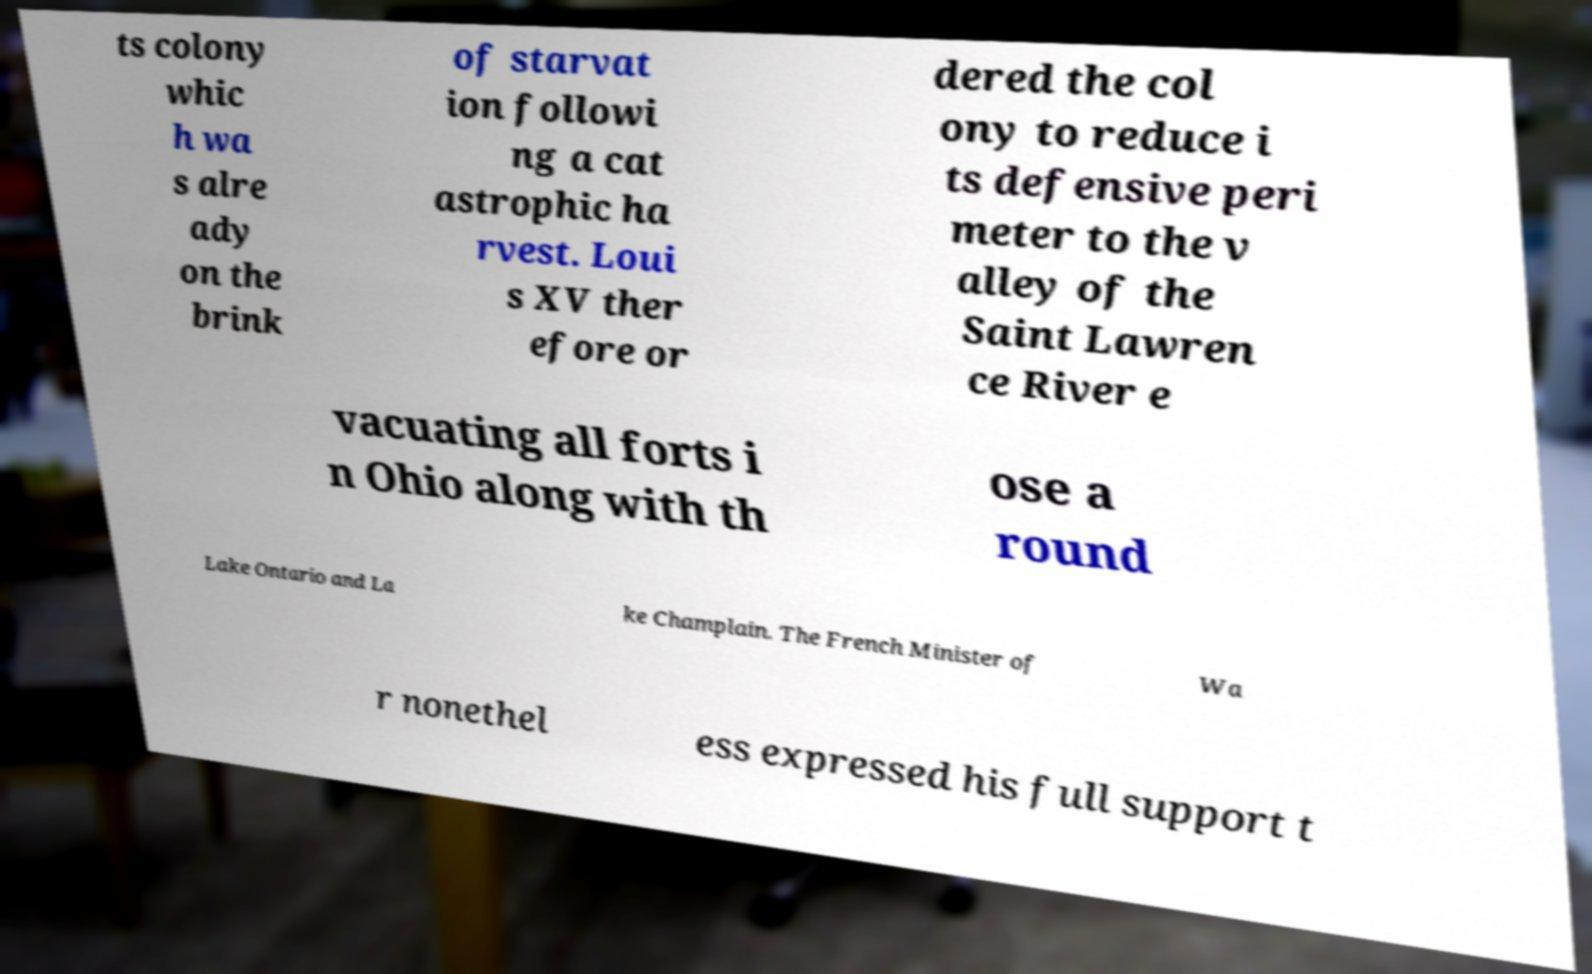Can you read and provide the text displayed in the image?This photo seems to have some interesting text. Can you extract and type it out for me? ts colony whic h wa s alre ady on the brink of starvat ion followi ng a cat astrophic ha rvest. Loui s XV ther efore or dered the col ony to reduce i ts defensive peri meter to the v alley of the Saint Lawren ce River e vacuating all forts i n Ohio along with th ose a round Lake Ontario and La ke Champlain. The French Minister of Wa r nonethel ess expressed his full support t 